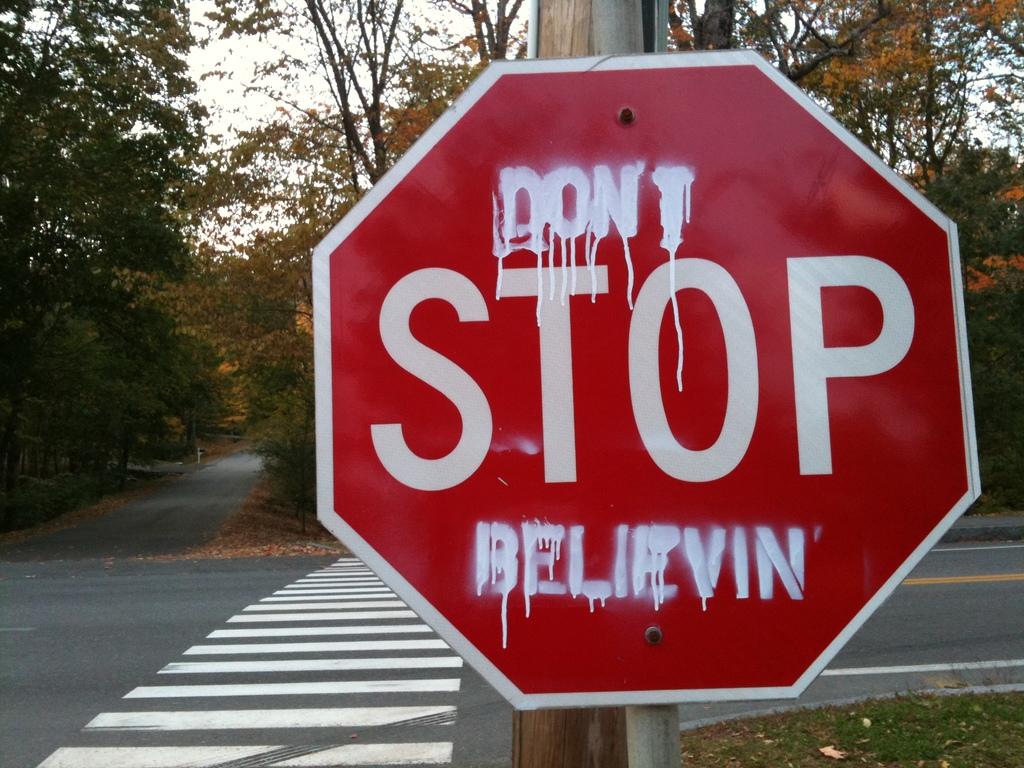Is this a stop sign?
Provide a short and direct response. Yes. What does the top word say?
Your answer should be very brief. Don't. 